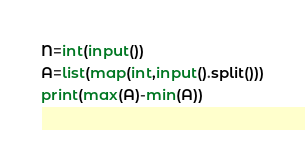<code> <loc_0><loc_0><loc_500><loc_500><_Python_>N=int(input())
A=list(map(int,input().split()))
print(max(A)-min(A))</code> 